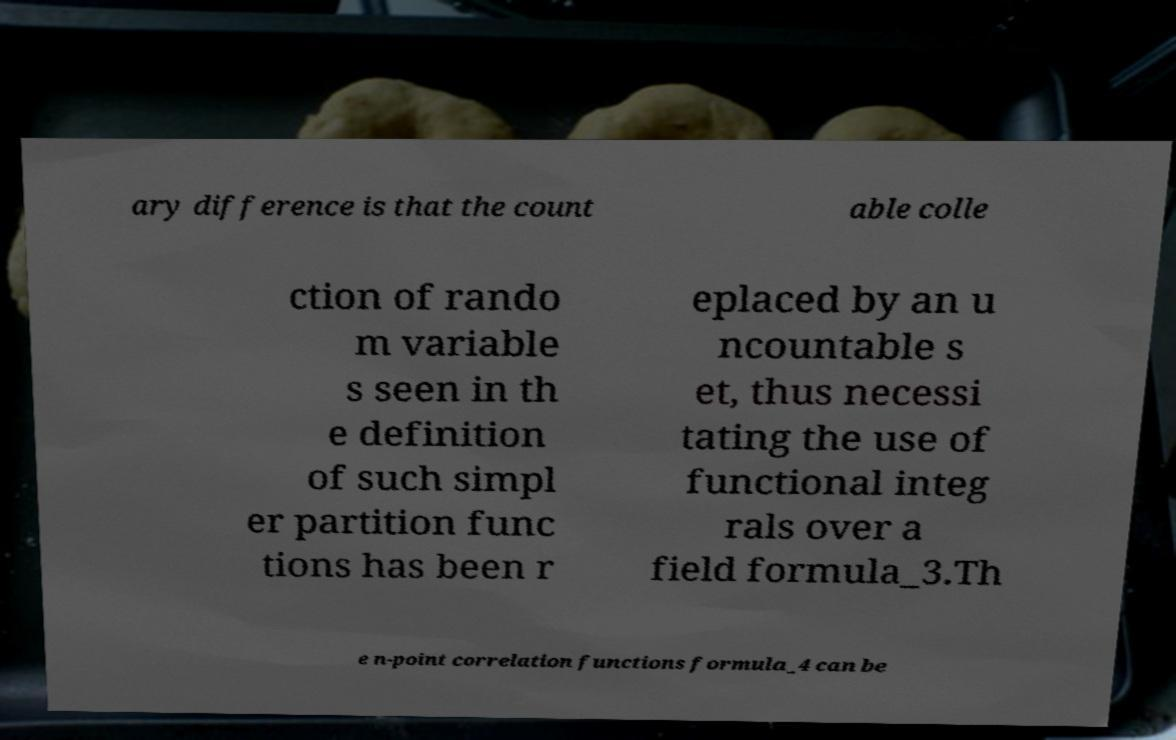Please read and relay the text visible in this image. What does it say? ary difference is that the count able colle ction of rando m variable s seen in th e definition of such simpl er partition func tions has been r eplaced by an u ncountable s et, thus necessi tating the use of functional integ rals over a field formula_3.Th e n-point correlation functions formula_4 can be 